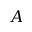Convert formula to latex. <formula><loc_0><loc_0><loc_500><loc_500>A</formula> 